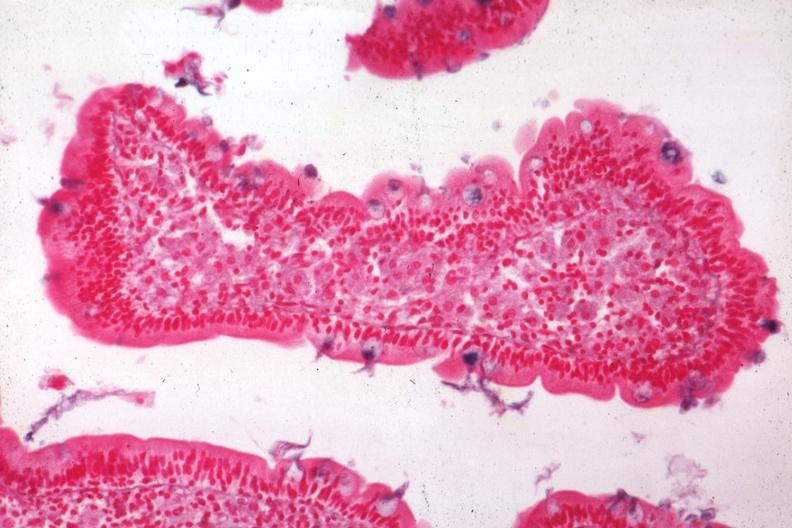what is present?
Answer the question using a single word or phrase. Gastrointestinal 